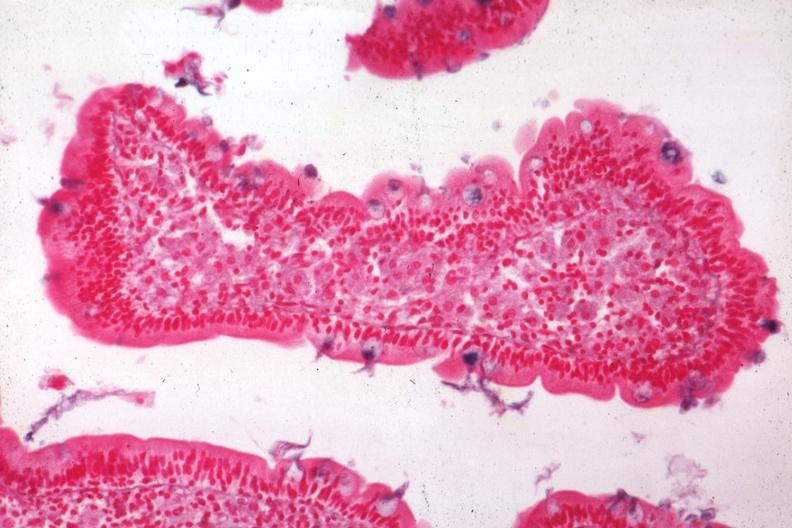what is present?
Answer the question using a single word or phrase. Gastrointestinal 